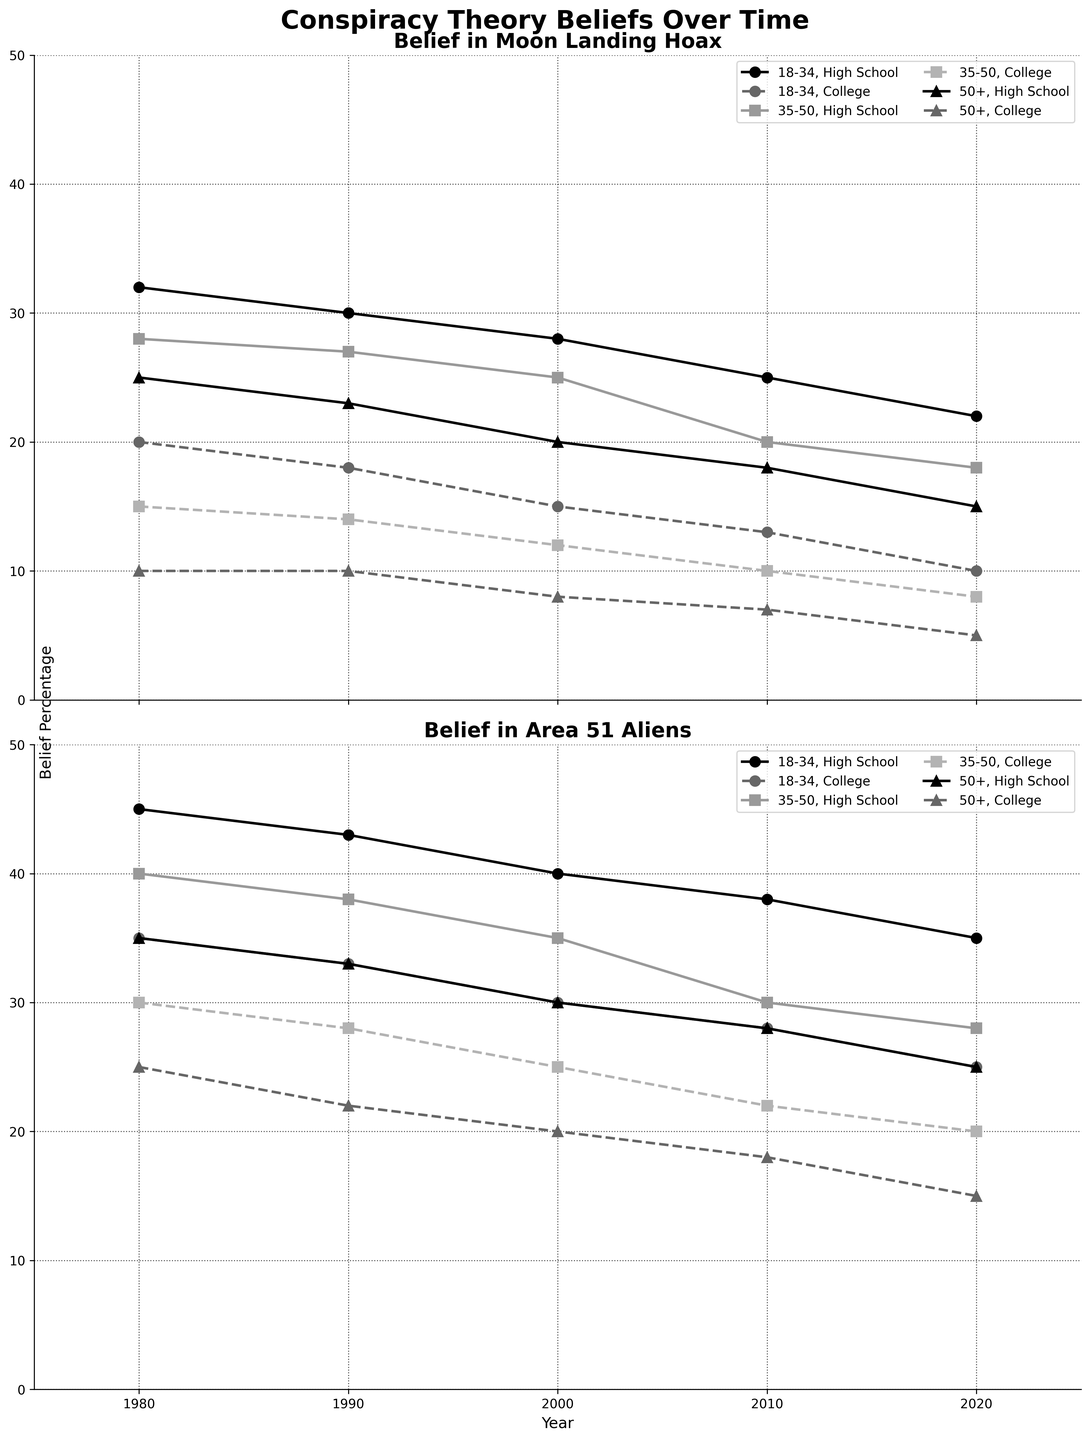Which group had the highest belief in the Moon Landing Hoax in 1980? Refer to the chart for 1980, look for the highest point in the Moon Landing Hoax belief section among all groups.
Answer: 18-34, High School How did the belief in Area 51 Aliens change for the 50+ age group with College education from 1980 to 2020? Locate the two points on the Area 51 Aliens belief line for the 50+ College group at 1980 and 2020 and calculate the difference.
Answer: Decreased by 10% Which age and education group recorded the lowest belief in the Moon Landing Hoax in 2020? Check each group's belief percentage for the Moon Landing Hoax in 2020; identify the group with the lowest value.
Answer: 50+, College What was the overall trend for belief in the Moon Landing Hoax from 1980 to 2020 for the 18-34 age group with High School education? Observe the trend line for the 18-34 High School group in the Moon Landing Hoax section from 1980 to 2020.
Answer: Decreasing Did any group's belief in Area 51 Aliens remain constant over the 40 years? Check the belief percentages across all four decades (1980, 1990, 2000, 2010, 2020) for any group in the Area 51 Aliens section to see if it stayed the same.
Answer: No Between the 35-50 and 50+ age groups with High School education, which group's belief in the Moon Landing Hoax showed a greater decline from 1980 to 2020? Calculate the difference in 1980 and 2020 values for both groups and compare the changes.
Answer: 35-50 age group Compare the belief in Area 51 Aliens in 2020 between the 18-34 age group with High School education and College education. Look at the 2020 data points for the 18-34 age group with both High School and College education in the Area 51 Aliens section.
Answer: Higher in High School by 10% What is the average belief in the Moon Landing Hoax for the 35-50 age group with College education across all years? Calculate the average of beliefs for the 35-50 College group in the Moon Landing Hoax section from 1980 to 2020.
Answer: 11.8% Which education level generally showed a lower belief in conspiracy theories across all age groups? Observe both belief lines and compare the data points for High School and College education levels.
Answer: College How does belief in Area 51 Aliens for the 18-34 age group with College education in 2000 compare to the 50+ age group with High School education in the same year? Directly compare the 2000 data points in the Area 51 Aliens section for 18-34 College and 50+ High School.
Answer: 18-34 College is lower by 10% 